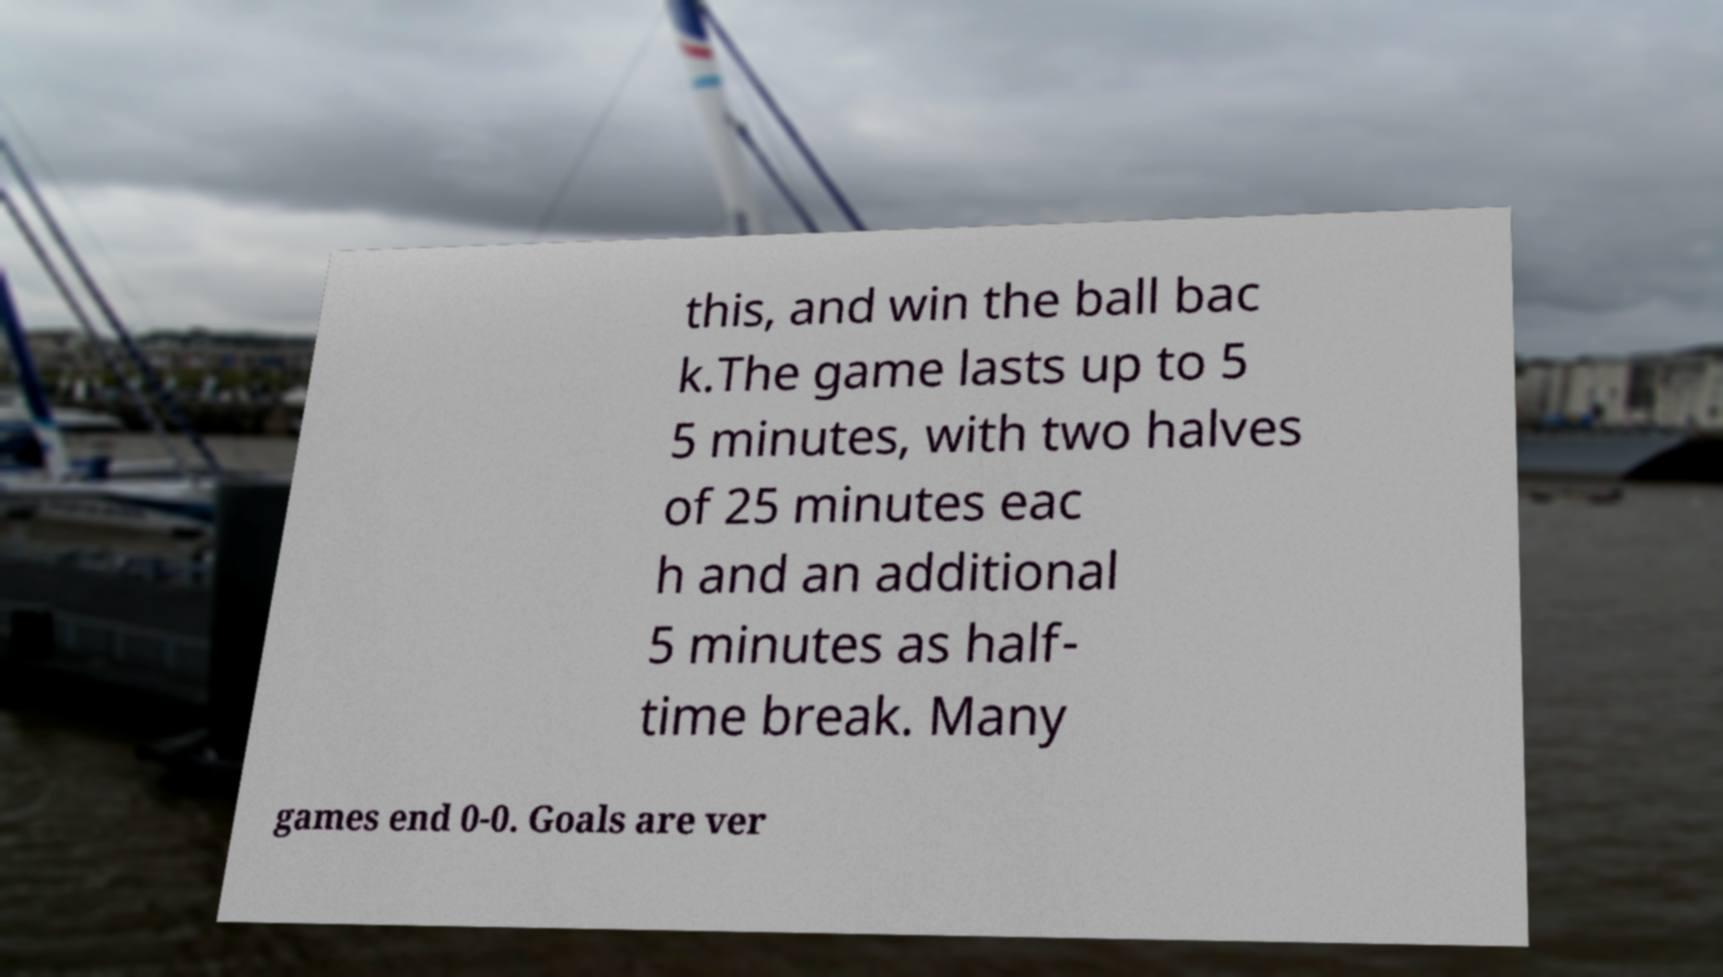Could you extract and type out the text from this image? this, and win the ball bac k.The game lasts up to 5 5 minutes, with two halves of 25 minutes eac h and an additional 5 minutes as half- time break. Many games end 0-0. Goals are ver 